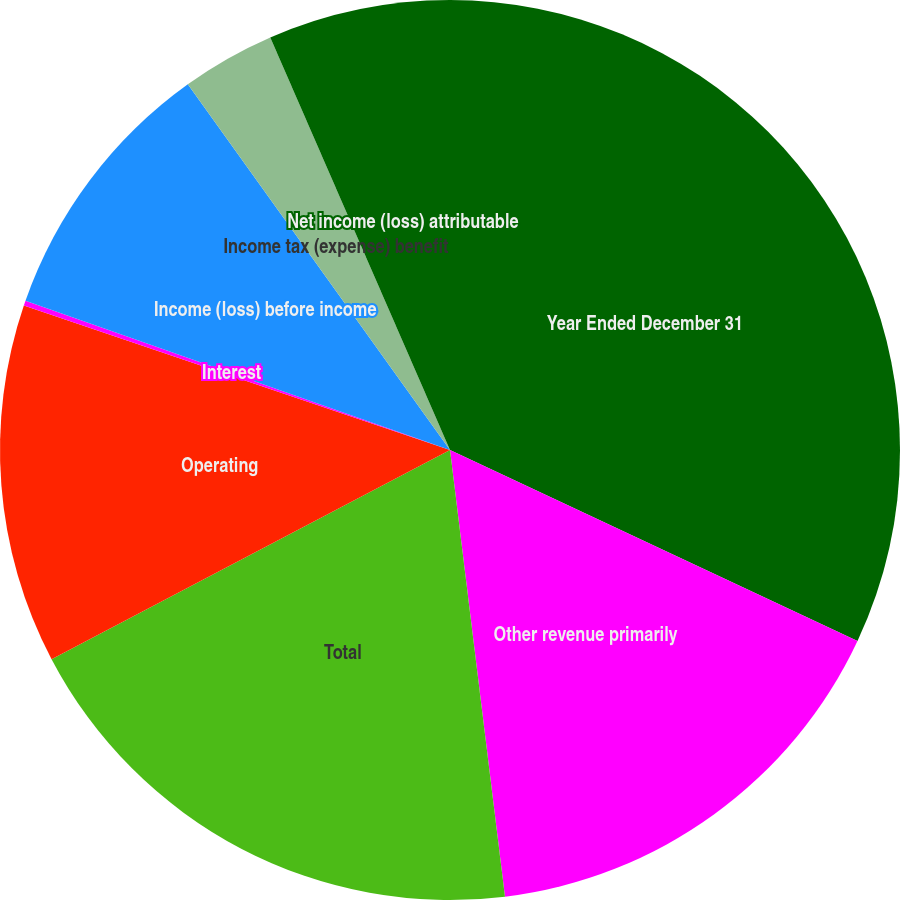Convert chart. <chart><loc_0><loc_0><loc_500><loc_500><pie_chart><fcel>Year Ended December 31<fcel>Other revenue primarily<fcel>Total<fcel>Operating<fcel>Interest<fcel>Income (loss) before income<fcel>Income tax (expense) benefit<fcel>Net income (loss) attributable<nl><fcel>31.98%<fcel>16.08%<fcel>19.26%<fcel>12.9%<fcel>0.18%<fcel>9.72%<fcel>3.36%<fcel>6.54%<nl></chart> 